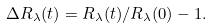<formula> <loc_0><loc_0><loc_500><loc_500>\Delta R _ { \lambda } ( t ) = R _ { \lambda } ( t ) / R _ { \lambda } ( 0 ) - 1 .</formula> 